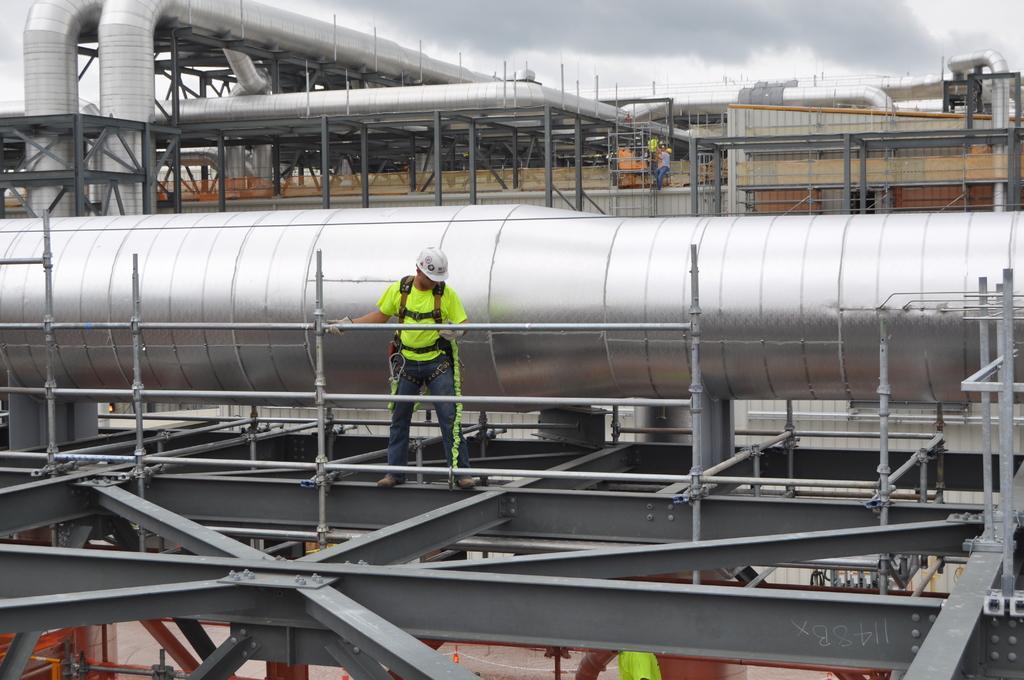Can you describe this image briefly? In this image we can see a person wearing green color T-shirt, blue color jeans also wearing white color helmet standing on rods, we can see some pipes and persons standing in the background of the image and top of the image there is cloudy sky. 